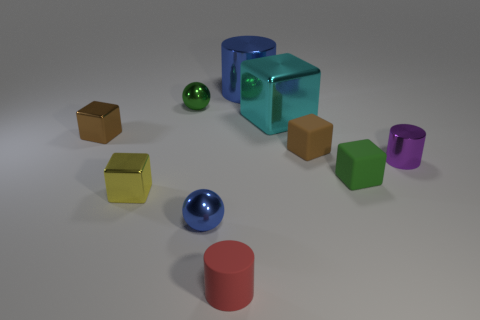There is a large cylinder; is it the same color as the ball in front of the tiny brown shiny block?
Give a very brief answer. Yes. There is a tiny object behind the large cyan block; what shape is it?
Your answer should be very brief. Sphere. What number of other objects are there of the same material as the purple thing?
Your answer should be very brief. 6. What is the cyan block made of?
Make the answer very short. Metal. How many tiny things are either blue spheres or gray metal things?
Give a very brief answer. 1. What number of cyan things are to the left of the big cyan object?
Your response must be concise. 0. Is there a small metal thing of the same color as the big cylinder?
Your response must be concise. Yes. What shape is the blue thing that is the same size as the cyan cube?
Offer a terse response. Cylinder. What number of yellow objects are small rubber objects or small cylinders?
Offer a terse response. 0. What number of spheres have the same size as the brown metallic thing?
Your answer should be compact. 2. 